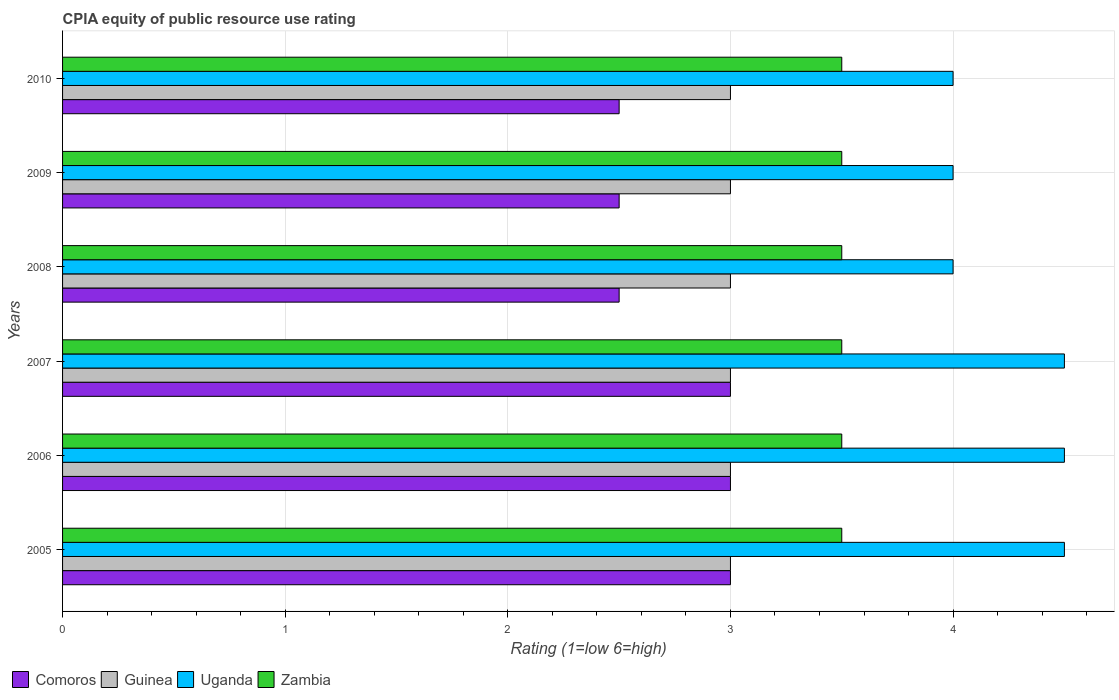How many different coloured bars are there?
Your response must be concise. 4. How many groups of bars are there?
Provide a short and direct response. 6. Are the number of bars per tick equal to the number of legend labels?
Offer a terse response. Yes. How many bars are there on the 2nd tick from the top?
Keep it short and to the point. 4. How many bars are there on the 1st tick from the bottom?
Offer a terse response. 4. What is the label of the 4th group of bars from the top?
Give a very brief answer. 2007. In how many cases, is the number of bars for a given year not equal to the number of legend labels?
Provide a succinct answer. 0. Across all years, what is the minimum CPIA rating in Uganda?
Offer a very short reply. 4. In which year was the CPIA rating in Comoros maximum?
Give a very brief answer. 2005. In which year was the CPIA rating in Zambia minimum?
Offer a very short reply. 2005. What is the difference between the CPIA rating in Uganda in 2008 and that in 2010?
Make the answer very short. 0. What is the difference between the highest and the second highest CPIA rating in Zambia?
Provide a succinct answer. 0. In how many years, is the CPIA rating in Uganda greater than the average CPIA rating in Uganda taken over all years?
Provide a short and direct response. 3. Is the sum of the CPIA rating in Zambia in 2005 and 2007 greater than the maximum CPIA rating in Guinea across all years?
Your answer should be compact. Yes. What does the 2nd bar from the top in 2007 represents?
Give a very brief answer. Uganda. What does the 3rd bar from the bottom in 2008 represents?
Your answer should be compact. Uganda. How many years are there in the graph?
Provide a short and direct response. 6. Are the values on the major ticks of X-axis written in scientific E-notation?
Ensure brevity in your answer.  No. Does the graph contain any zero values?
Your answer should be very brief. No. Where does the legend appear in the graph?
Provide a succinct answer. Bottom left. How many legend labels are there?
Keep it short and to the point. 4. How are the legend labels stacked?
Keep it short and to the point. Horizontal. What is the title of the graph?
Your response must be concise. CPIA equity of public resource use rating. What is the Rating (1=low 6=high) of Guinea in 2005?
Make the answer very short. 3. What is the Rating (1=low 6=high) of Uganda in 2005?
Provide a short and direct response. 4.5. What is the Rating (1=low 6=high) in Zambia in 2005?
Offer a terse response. 3.5. What is the Rating (1=low 6=high) in Guinea in 2006?
Your answer should be very brief. 3. What is the Rating (1=low 6=high) of Uganda in 2006?
Give a very brief answer. 4.5. What is the Rating (1=low 6=high) of Zambia in 2006?
Offer a terse response. 3.5. What is the Rating (1=low 6=high) of Comoros in 2007?
Provide a succinct answer. 3. What is the Rating (1=low 6=high) of Guinea in 2007?
Provide a succinct answer. 3. What is the Rating (1=low 6=high) in Uganda in 2007?
Give a very brief answer. 4.5. What is the Rating (1=low 6=high) in Zambia in 2007?
Keep it short and to the point. 3.5. What is the Rating (1=low 6=high) in Comoros in 2008?
Your answer should be very brief. 2.5. What is the Rating (1=low 6=high) in Guinea in 2008?
Keep it short and to the point. 3. What is the Rating (1=low 6=high) of Uganda in 2008?
Your answer should be very brief. 4. What is the Rating (1=low 6=high) in Zambia in 2008?
Make the answer very short. 3.5. What is the Rating (1=low 6=high) of Comoros in 2009?
Ensure brevity in your answer.  2.5. What is the Rating (1=low 6=high) in Uganda in 2009?
Your answer should be very brief. 4. What is the Rating (1=low 6=high) in Zambia in 2009?
Ensure brevity in your answer.  3.5. What is the Rating (1=low 6=high) in Guinea in 2010?
Keep it short and to the point. 3. What is the Rating (1=low 6=high) in Uganda in 2010?
Provide a succinct answer. 4. What is the Rating (1=low 6=high) in Zambia in 2010?
Keep it short and to the point. 3.5. Across all years, what is the maximum Rating (1=low 6=high) in Comoros?
Your answer should be compact. 3. Across all years, what is the maximum Rating (1=low 6=high) of Guinea?
Give a very brief answer. 3. Across all years, what is the maximum Rating (1=low 6=high) of Uganda?
Your response must be concise. 4.5. Across all years, what is the maximum Rating (1=low 6=high) in Zambia?
Offer a very short reply. 3.5. Across all years, what is the minimum Rating (1=low 6=high) of Comoros?
Make the answer very short. 2.5. Across all years, what is the minimum Rating (1=low 6=high) of Guinea?
Your answer should be very brief. 3. Across all years, what is the minimum Rating (1=low 6=high) of Uganda?
Provide a short and direct response. 4. What is the total Rating (1=low 6=high) in Uganda in the graph?
Give a very brief answer. 25.5. What is the total Rating (1=low 6=high) in Zambia in the graph?
Your response must be concise. 21. What is the difference between the Rating (1=low 6=high) of Uganda in 2005 and that in 2006?
Provide a succinct answer. 0. What is the difference between the Rating (1=low 6=high) of Zambia in 2005 and that in 2006?
Offer a very short reply. 0. What is the difference between the Rating (1=low 6=high) in Comoros in 2005 and that in 2007?
Your answer should be compact. 0. What is the difference between the Rating (1=low 6=high) of Comoros in 2005 and that in 2008?
Your answer should be compact. 0.5. What is the difference between the Rating (1=low 6=high) in Guinea in 2005 and that in 2008?
Offer a terse response. 0. What is the difference between the Rating (1=low 6=high) in Guinea in 2005 and that in 2009?
Offer a very short reply. 0. What is the difference between the Rating (1=low 6=high) of Uganda in 2005 and that in 2009?
Give a very brief answer. 0.5. What is the difference between the Rating (1=low 6=high) in Uganda in 2005 and that in 2010?
Make the answer very short. 0.5. What is the difference between the Rating (1=low 6=high) of Guinea in 2006 and that in 2007?
Ensure brevity in your answer.  0. What is the difference between the Rating (1=low 6=high) in Comoros in 2006 and that in 2008?
Provide a short and direct response. 0.5. What is the difference between the Rating (1=low 6=high) of Zambia in 2006 and that in 2008?
Provide a short and direct response. 0. What is the difference between the Rating (1=low 6=high) of Uganda in 2006 and that in 2009?
Keep it short and to the point. 0.5. What is the difference between the Rating (1=low 6=high) in Uganda in 2006 and that in 2010?
Your response must be concise. 0.5. What is the difference between the Rating (1=low 6=high) in Comoros in 2007 and that in 2008?
Provide a short and direct response. 0.5. What is the difference between the Rating (1=low 6=high) of Zambia in 2007 and that in 2008?
Your response must be concise. 0. What is the difference between the Rating (1=low 6=high) of Zambia in 2007 and that in 2009?
Give a very brief answer. 0. What is the difference between the Rating (1=low 6=high) in Comoros in 2007 and that in 2010?
Keep it short and to the point. 0.5. What is the difference between the Rating (1=low 6=high) in Zambia in 2007 and that in 2010?
Provide a short and direct response. 0. What is the difference between the Rating (1=low 6=high) in Guinea in 2008 and that in 2009?
Provide a succinct answer. 0. What is the difference between the Rating (1=low 6=high) in Uganda in 2008 and that in 2009?
Provide a succinct answer. 0. What is the difference between the Rating (1=low 6=high) in Zambia in 2008 and that in 2010?
Your answer should be compact. 0. What is the difference between the Rating (1=low 6=high) in Comoros in 2009 and that in 2010?
Your response must be concise. 0. What is the difference between the Rating (1=low 6=high) of Uganda in 2009 and that in 2010?
Offer a terse response. 0. What is the difference between the Rating (1=low 6=high) in Zambia in 2009 and that in 2010?
Keep it short and to the point. 0. What is the difference between the Rating (1=low 6=high) of Comoros in 2005 and the Rating (1=low 6=high) of Guinea in 2006?
Your answer should be very brief. 0. What is the difference between the Rating (1=low 6=high) in Comoros in 2005 and the Rating (1=low 6=high) in Uganda in 2006?
Your response must be concise. -1.5. What is the difference between the Rating (1=low 6=high) in Comoros in 2005 and the Rating (1=low 6=high) in Zambia in 2006?
Your answer should be compact. -0.5. What is the difference between the Rating (1=low 6=high) of Guinea in 2005 and the Rating (1=low 6=high) of Uganda in 2006?
Offer a very short reply. -1.5. What is the difference between the Rating (1=low 6=high) in Guinea in 2005 and the Rating (1=low 6=high) in Zambia in 2006?
Provide a succinct answer. -0.5. What is the difference between the Rating (1=low 6=high) of Uganda in 2005 and the Rating (1=low 6=high) of Zambia in 2006?
Your answer should be compact. 1. What is the difference between the Rating (1=low 6=high) in Comoros in 2005 and the Rating (1=low 6=high) in Guinea in 2007?
Give a very brief answer. 0. What is the difference between the Rating (1=low 6=high) of Comoros in 2005 and the Rating (1=low 6=high) of Uganda in 2007?
Make the answer very short. -1.5. What is the difference between the Rating (1=low 6=high) of Comoros in 2005 and the Rating (1=low 6=high) of Zambia in 2007?
Keep it short and to the point. -0.5. What is the difference between the Rating (1=low 6=high) of Guinea in 2005 and the Rating (1=low 6=high) of Zambia in 2007?
Ensure brevity in your answer.  -0.5. What is the difference between the Rating (1=low 6=high) in Uganda in 2005 and the Rating (1=low 6=high) in Zambia in 2007?
Offer a terse response. 1. What is the difference between the Rating (1=low 6=high) in Comoros in 2005 and the Rating (1=low 6=high) in Uganda in 2008?
Offer a very short reply. -1. What is the difference between the Rating (1=low 6=high) of Comoros in 2005 and the Rating (1=low 6=high) of Zambia in 2009?
Give a very brief answer. -0.5. What is the difference between the Rating (1=low 6=high) of Uganda in 2005 and the Rating (1=low 6=high) of Zambia in 2009?
Provide a succinct answer. 1. What is the difference between the Rating (1=low 6=high) in Comoros in 2005 and the Rating (1=low 6=high) in Guinea in 2010?
Give a very brief answer. 0. What is the difference between the Rating (1=low 6=high) of Comoros in 2005 and the Rating (1=low 6=high) of Uganda in 2010?
Make the answer very short. -1. What is the difference between the Rating (1=low 6=high) in Comoros in 2005 and the Rating (1=low 6=high) in Zambia in 2010?
Ensure brevity in your answer.  -0.5. What is the difference between the Rating (1=low 6=high) in Comoros in 2006 and the Rating (1=low 6=high) in Uganda in 2007?
Make the answer very short. -1.5. What is the difference between the Rating (1=low 6=high) in Comoros in 2006 and the Rating (1=low 6=high) in Guinea in 2008?
Make the answer very short. 0. What is the difference between the Rating (1=low 6=high) in Comoros in 2006 and the Rating (1=low 6=high) in Uganda in 2008?
Your response must be concise. -1. What is the difference between the Rating (1=low 6=high) in Comoros in 2006 and the Rating (1=low 6=high) in Zambia in 2008?
Provide a succinct answer. -0.5. What is the difference between the Rating (1=low 6=high) of Guinea in 2006 and the Rating (1=low 6=high) of Uganda in 2008?
Give a very brief answer. -1. What is the difference between the Rating (1=low 6=high) in Guinea in 2006 and the Rating (1=low 6=high) in Zambia in 2008?
Make the answer very short. -0.5. What is the difference between the Rating (1=low 6=high) of Comoros in 2006 and the Rating (1=low 6=high) of Guinea in 2009?
Offer a terse response. 0. What is the difference between the Rating (1=low 6=high) of Comoros in 2006 and the Rating (1=low 6=high) of Uganda in 2009?
Keep it short and to the point. -1. What is the difference between the Rating (1=low 6=high) in Comoros in 2006 and the Rating (1=low 6=high) in Zambia in 2009?
Your answer should be compact. -0.5. What is the difference between the Rating (1=low 6=high) of Guinea in 2006 and the Rating (1=low 6=high) of Uganda in 2009?
Your answer should be very brief. -1. What is the difference between the Rating (1=low 6=high) of Guinea in 2006 and the Rating (1=low 6=high) of Zambia in 2009?
Provide a short and direct response. -0.5. What is the difference between the Rating (1=low 6=high) of Uganda in 2006 and the Rating (1=low 6=high) of Zambia in 2009?
Give a very brief answer. 1. What is the difference between the Rating (1=low 6=high) in Comoros in 2006 and the Rating (1=low 6=high) in Guinea in 2010?
Offer a terse response. 0. What is the difference between the Rating (1=low 6=high) of Comoros in 2006 and the Rating (1=low 6=high) of Uganda in 2010?
Offer a very short reply. -1. What is the difference between the Rating (1=low 6=high) in Comoros in 2006 and the Rating (1=low 6=high) in Zambia in 2010?
Give a very brief answer. -0.5. What is the difference between the Rating (1=low 6=high) of Guinea in 2006 and the Rating (1=low 6=high) of Uganda in 2010?
Ensure brevity in your answer.  -1. What is the difference between the Rating (1=low 6=high) of Comoros in 2007 and the Rating (1=low 6=high) of Uganda in 2008?
Offer a very short reply. -1. What is the difference between the Rating (1=low 6=high) of Guinea in 2007 and the Rating (1=low 6=high) of Zambia in 2008?
Your answer should be compact. -0.5. What is the difference between the Rating (1=low 6=high) in Uganda in 2007 and the Rating (1=low 6=high) in Zambia in 2008?
Provide a succinct answer. 1. What is the difference between the Rating (1=low 6=high) of Comoros in 2007 and the Rating (1=low 6=high) of Uganda in 2009?
Provide a succinct answer. -1. What is the difference between the Rating (1=low 6=high) in Guinea in 2007 and the Rating (1=low 6=high) in Uganda in 2009?
Offer a very short reply. -1. What is the difference between the Rating (1=low 6=high) in Uganda in 2007 and the Rating (1=low 6=high) in Zambia in 2009?
Offer a very short reply. 1. What is the difference between the Rating (1=low 6=high) in Comoros in 2007 and the Rating (1=low 6=high) in Uganda in 2010?
Your answer should be compact. -1. What is the difference between the Rating (1=low 6=high) in Guinea in 2007 and the Rating (1=low 6=high) in Uganda in 2010?
Offer a terse response. -1. What is the difference between the Rating (1=low 6=high) in Guinea in 2007 and the Rating (1=low 6=high) in Zambia in 2010?
Your answer should be compact. -0.5. What is the difference between the Rating (1=low 6=high) of Comoros in 2008 and the Rating (1=low 6=high) of Zambia in 2009?
Offer a terse response. -1. What is the difference between the Rating (1=low 6=high) in Uganda in 2008 and the Rating (1=low 6=high) in Zambia in 2009?
Make the answer very short. 0.5. What is the difference between the Rating (1=low 6=high) in Comoros in 2008 and the Rating (1=low 6=high) in Guinea in 2010?
Your answer should be very brief. -0.5. What is the difference between the Rating (1=low 6=high) in Comoros in 2008 and the Rating (1=low 6=high) in Zambia in 2010?
Your response must be concise. -1. What is the difference between the Rating (1=low 6=high) in Guinea in 2008 and the Rating (1=low 6=high) in Uganda in 2010?
Your answer should be very brief. -1. What is the difference between the Rating (1=low 6=high) of Guinea in 2008 and the Rating (1=low 6=high) of Zambia in 2010?
Keep it short and to the point. -0.5. What is the difference between the Rating (1=low 6=high) in Comoros in 2009 and the Rating (1=low 6=high) in Guinea in 2010?
Keep it short and to the point. -0.5. What is the difference between the Rating (1=low 6=high) in Guinea in 2009 and the Rating (1=low 6=high) in Uganda in 2010?
Your answer should be very brief. -1. What is the difference between the Rating (1=low 6=high) in Guinea in 2009 and the Rating (1=low 6=high) in Zambia in 2010?
Offer a very short reply. -0.5. What is the difference between the Rating (1=low 6=high) in Uganda in 2009 and the Rating (1=low 6=high) in Zambia in 2010?
Your response must be concise. 0.5. What is the average Rating (1=low 6=high) in Comoros per year?
Ensure brevity in your answer.  2.75. What is the average Rating (1=low 6=high) in Uganda per year?
Make the answer very short. 4.25. What is the average Rating (1=low 6=high) in Zambia per year?
Make the answer very short. 3.5. In the year 2005, what is the difference between the Rating (1=low 6=high) in Comoros and Rating (1=low 6=high) in Uganda?
Make the answer very short. -1.5. In the year 2005, what is the difference between the Rating (1=low 6=high) in Guinea and Rating (1=low 6=high) in Zambia?
Keep it short and to the point. -0.5. In the year 2005, what is the difference between the Rating (1=low 6=high) in Uganda and Rating (1=low 6=high) in Zambia?
Provide a short and direct response. 1. In the year 2006, what is the difference between the Rating (1=low 6=high) in Comoros and Rating (1=low 6=high) in Uganda?
Ensure brevity in your answer.  -1.5. In the year 2006, what is the difference between the Rating (1=low 6=high) in Guinea and Rating (1=low 6=high) in Zambia?
Give a very brief answer. -0.5. In the year 2007, what is the difference between the Rating (1=low 6=high) in Comoros and Rating (1=low 6=high) in Zambia?
Provide a short and direct response. -0.5. In the year 2007, what is the difference between the Rating (1=low 6=high) in Guinea and Rating (1=low 6=high) in Uganda?
Provide a short and direct response. -1.5. In the year 2007, what is the difference between the Rating (1=low 6=high) of Guinea and Rating (1=low 6=high) of Zambia?
Your answer should be compact. -0.5. In the year 2007, what is the difference between the Rating (1=low 6=high) of Uganda and Rating (1=low 6=high) of Zambia?
Your answer should be compact. 1. In the year 2008, what is the difference between the Rating (1=low 6=high) in Comoros and Rating (1=low 6=high) in Guinea?
Your response must be concise. -0.5. In the year 2008, what is the difference between the Rating (1=low 6=high) in Uganda and Rating (1=low 6=high) in Zambia?
Provide a succinct answer. 0.5. In the year 2009, what is the difference between the Rating (1=low 6=high) of Comoros and Rating (1=low 6=high) of Guinea?
Make the answer very short. -0.5. In the year 2009, what is the difference between the Rating (1=low 6=high) in Comoros and Rating (1=low 6=high) in Uganda?
Ensure brevity in your answer.  -1.5. In the year 2009, what is the difference between the Rating (1=low 6=high) of Guinea and Rating (1=low 6=high) of Uganda?
Offer a terse response. -1. In the year 2010, what is the difference between the Rating (1=low 6=high) in Comoros and Rating (1=low 6=high) in Guinea?
Your answer should be compact. -0.5. In the year 2010, what is the difference between the Rating (1=low 6=high) of Comoros and Rating (1=low 6=high) of Uganda?
Make the answer very short. -1.5. In the year 2010, what is the difference between the Rating (1=low 6=high) of Comoros and Rating (1=low 6=high) of Zambia?
Offer a very short reply. -1. In the year 2010, what is the difference between the Rating (1=low 6=high) in Guinea and Rating (1=low 6=high) in Uganda?
Provide a succinct answer. -1. What is the ratio of the Rating (1=low 6=high) of Comoros in 2005 to that in 2006?
Offer a terse response. 1. What is the ratio of the Rating (1=low 6=high) in Uganda in 2005 to that in 2006?
Make the answer very short. 1. What is the ratio of the Rating (1=low 6=high) of Zambia in 2005 to that in 2006?
Provide a short and direct response. 1. What is the ratio of the Rating (1=low 6=high) of Uganda in 2005 to that in 2007?
Your answer should be compact. 1. What is the ratio of the Rating (1=low 6=high) in Zambia in 2005 to that in 2007?
Offer a terse response. 1. What is the ratio of the Rating (1=low 6=high) of Guinea in 2005 to that in 2008?
Ensure brevity in your answer.  1. What is the ratio of the Rating (1=low 6=high) in Zambia in 2005 to that in 2008?
Offer a very short reply. 1. What is the ratio of the Rating (1=low 6=high) of Uganda in 2005 to that in 2009?
Give a very brief answer. 1.12. What is the ratio of the Rating (1=low 6=high) in Zambia in 2005 to that in 2009?
Your response must be concise. 1. What is the ratio of the Rating (1=low 6=high) of Comoros in 2005 to that in 2010?
Keep it short and to the point. 1.2. What is the ratio of the Rating (1=low 6=high) of Guinea in 2005 to that in 2010?
Your response must be concise. 1. What is the ratio of the Rating (1=low 6=high) of Uganda in 2006 to that in 2007?
Offer a terse response. 1. What is the ratio of the Rating (1=low 6=high) in Zambia in 2006 to that in 2007?
Offer a terse response. 1. What is the ratio of the Rating (1=low 6=high) in Comoros in 2006 to that in 2008?
Provide a short and direct response. 1.2. What is the ratio of the Rating (1=low 6=high) in Comoros in 2006 to that in 2009?
Ensure brevity in your answer.  1.2. What is the ratio of the Rating (1=low 6=high) of Guinea in 2006 to that in 2009?
Keep it short and to the point. 1. What is the ratio of the Rating (1=low 6=high) in Zambia in 2006 to that in 2009?
Your response must be concise. 1. What is the ratio of the Rating (1=low 6=high) of Comoros in 2007 to that in 2008?
Keep it short and to the point. 1.2. What is the ratio of the Rating (1=low 6=high) in Uganda in 2007 to that in 2008?
Keep it short and to the point. 1.12. What is the ratio of the Rating (1=low 6=high) of Zambia in 2007 to that in 2008?
Your answer should be compact. 1. What is the ratio of the Rating (1=low 6=high) of Comoros in 2007 to that in 2009?
Your answer should be compact. 1.2. What is the ratio of the Rating (1=low 6=high) in Uganda in 2007 to that in 2009?
Ensure brevity in your answer.  1.12. What is the ratio of the Rating (1=low 6=high) in Zambia in 2007 to that in 2009?
Provide a short and direct response. 1. What is the ratio of the Rating (1=low 6=high) of Guinea in 2007 to that in 2010?
Your answer should be compact. 1. What is the ratio of the Rating (1=low 6=high) of Uganda in 2007 to that in 2010?
Offer a terse response. 1.12. What is the ratio of the Rating (1=low 6=high) of Zambia in 2007 to that in 2010?
Your answer should be compact. 1. What is the ratio of the Rating (1=low 6=high) in Comoros in 2008 to that in 2010?
Give a very brief answer. 1. What is the ratio of the Rating (1=low 6=high) of Uganda in 2008 to that in 2010?
Ensure brevity in your answer.  1. What is the ratio of the Rating (1=low 6=high) of Zambia in 2008 to that in 2010?
Offer a terse response. 1. What is the ratio of the Rating (1=low 6=high) of Guinea in 2009 to that in 2010?
Make the answer very short. 1. What is the difference between the highest and the second highest Rating (1=low 6=high) in Uganda?
Provide a short and direct response. 0. What is the difference between the highest and the second highest Rating (1=low 6=high) in Zambia?
Give a very brief answer. 0. What is the difference between the highest and the lowest Rating (1=low 6=high) of Comoros?
Ensure brevity in your answer.  0.5. What is the difference between the highest and the lowest Rating (1=low 6=high) of Zambia?
Your answer should be compact. 0. 